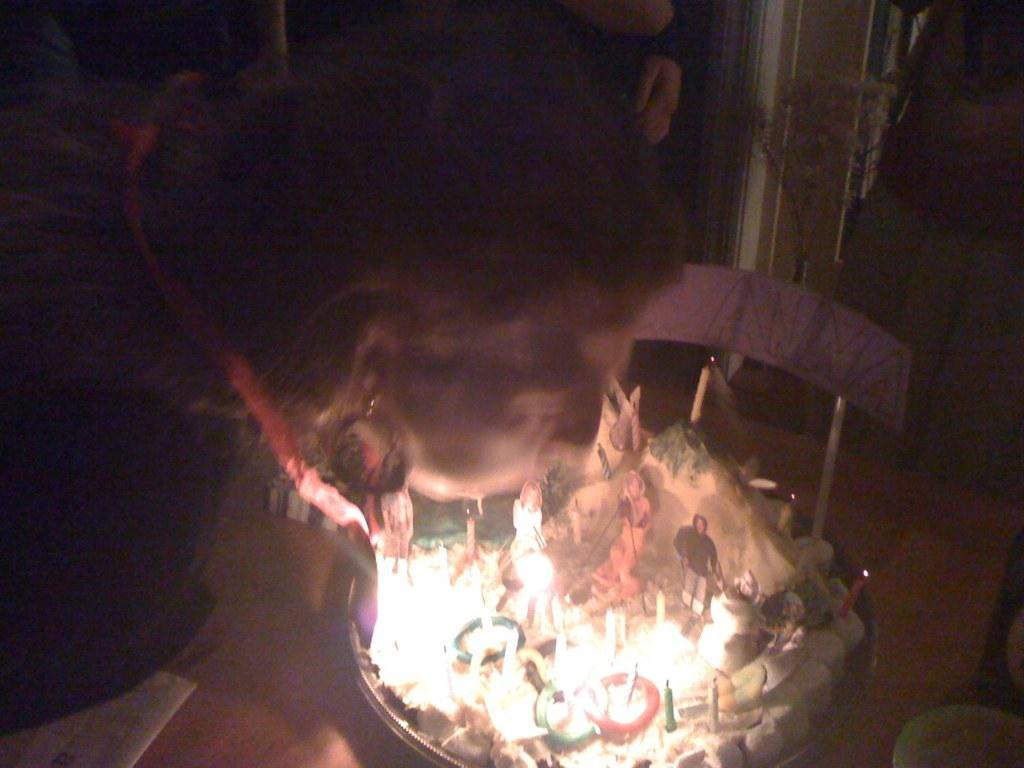Who is the main subject in the image? There is a woman in the image. What is the woman doing in the image? The woman is blowing out candles. Where are the candles located? The candles are on a cake. How is the cake positioned in relation to the woman? The cake is in front of the woman. On what is the cake placed? The cake is placed on a chair. What type of ornament can be seen hanging from the woman's face in the image? There is no ornament hanging from the woman's face in the image. 